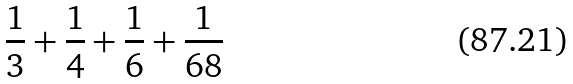<formula> <loc_0><loc_0><loc_500><loc_500>\frac { 1 } { 3 } + \frac { 1 } { 4 } + \frac { 1 } { 6 } + \frac { 1 } { 6 8 }</formula> 